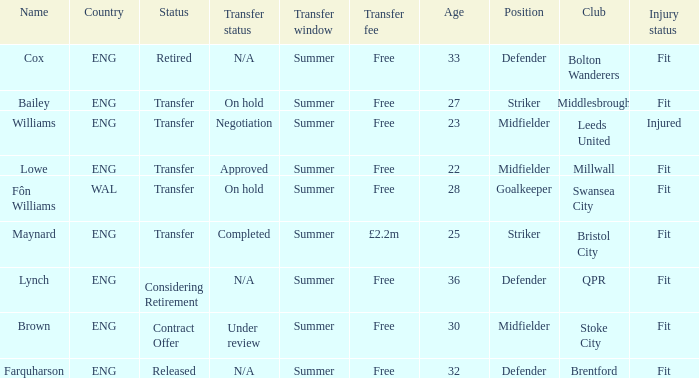What is the status of the Eng Country from the Maynard name? Transfer. 